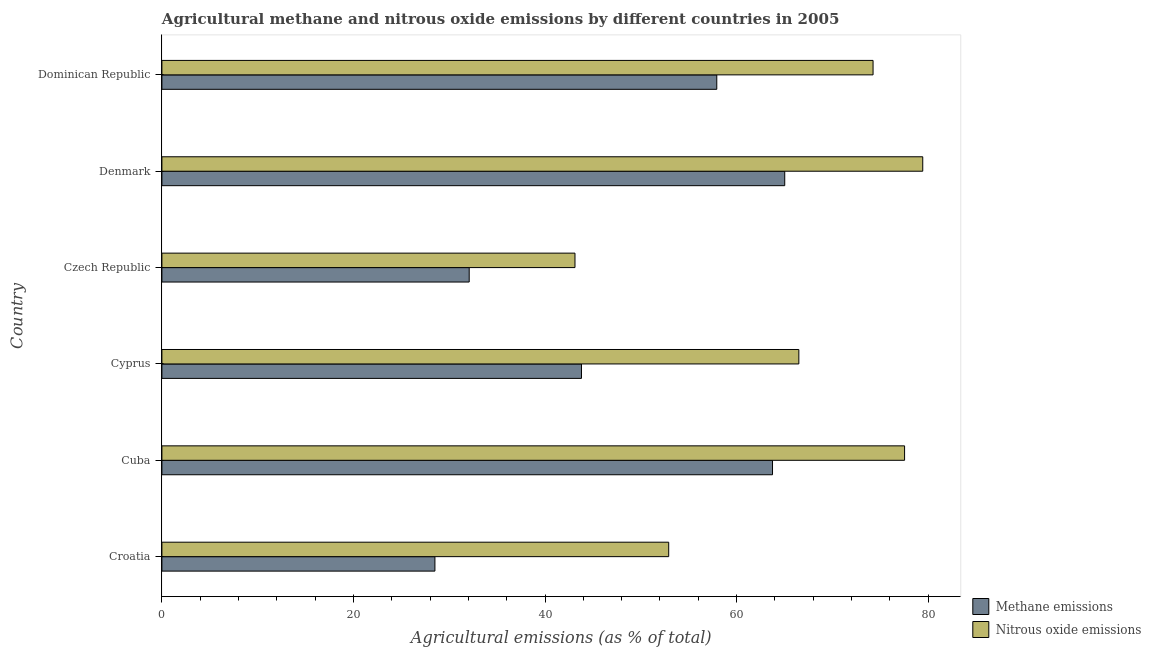How many different coloured bars are there?
Ensure brevity in your answer.  2. How many groups of bars are there?
Offer a terse response. 6. Are the number of bars per tick equal to the number of legend labels?
Offer a terse response. Yes. What is the label of the 2nd group of bars from the top?
Give a very brief answer. Denmark. In how many cases, is the number of bars for a given country not equal to the number of legend labels?
Offer a terse response. 0. What is the amount of methane emissions in Dominican Republic?
Offer a terse response. 57.94. Across all countries, what is the maximum amount of nitrous oxide emissions?
Your response must be concise. 79.44. Across all countries, what is the minimum amount of nitrous oxide emissions?
Your answer should be compact. 43.13. In which country was the amount of nitrous oxide emissions maximum?
Provide a short and direct response. Denmark. In which country was the amount of methane emissions minimum?
Provide a short and direct response. Croatia. What is the total amount of methane emissions in the graph?
Keep it short and to the point. 291.12. What is the difference between the amount of methane emissions in Croatia and that in Denmark?
Make the answer very short. -36.52. What is the difference between the amount of nitrous oxide emissions in Dominican Republic and the amount of methane emissions in Cuba?
Offer a very short reply. 10.5. What is the average amount of nitrous oxide emissions per country?
Your answer should be compact. 65.63. What is the difference between the amount of nitrous oxide emissions and amount of methane emissions in Dominican Republic?
Keep it short and to the point. 16.32. What is the ratio of the amount of methane emissions in Cuba to that in Denmark?
Your answer should be compact. 0.98. What is the difference between the highest and the second highest amount of methane emissions?
Your answer should be compact. 1.27. What is the difference between the highest and the lowest amount of nitrous oxide emissions?
Your answer should be very brief. 36.31. In how many countries, is the amount of nitrous oxide emissions greater than the average amount of nitrous oxide emissions taken over all countries?
Provide a short and direct response. 4. What does the 2nd bar from the top in Cyprus represents?
Keep it short and to the point. Methane emissions. What does the 1st bar from the bottom in Czech Republic represents?
Give a very brief answer. Methane emissions. How many bars are there?
Offer a terse response. 12. Are all the bars in the graph horizontal?
Keep it short and to the point. Yes. What is the difference between two consecutive major ticks on the X-axis?
Ensure brevity in your answer.  20. Are the values on the major ticks of X-axis written in scientific E-notation?
Offer a terse response. No. Does the graph contain any zero values?
Your answer should be very brief. No. Does the graph contain grids?
Keep it short and to the point. No. Where does the legend appear in the graph?
Ensure brevity in your answer.  Bottom right. How are the legend labels stacked?
Offer a very short reply. Vertical. What is the title of the graph?
Ensure brevity in your answer.  Agricultural methane and nitrous oxide emissions by different countries in 2005. What is the label or title of the X-axis?
Your answer should be very brief. Agricultural emissions (as % of total). What is the Agricultural emissions (as % of total) in Methane emissions in Croatia?
Give a very brief answer. 28.51. What is the Agricultural emissions (as % of total) of Nitrous oxide emissions in Croatia?
Provide a succinct answer. 52.91. What is the Agricultural emissions (as % of total) of Methane emissions in Cuba?
Make the answer very short. 63.76. What is the Agricultural emissions (as % of total) of Nitrous oxide emissions in Cuba?
Provide a succinct answer. 77.54. What is the Agricultural emissions (as % of total) of Methane emissions in Cyprus?
Your answer should be compact. 43.81. What is the Agricultural emissions (as % of total) of Nitrous oxide emissions in Cyprus?
Make the answer very short. 66.5. What is the Agricultural emissions (as % of total) in Methane emissions in Czech Republic?
Provide a short and direct response. 32.09. What is the Agricultural emissions (as % of total) of Nitrous oxide emissions in Czech Republic?
Your answer should be very brief. 43.13. What is the Agricultural emissions (as % of total) in Methane emissions in Denmark?
Offer a terse response. 65.03. What is the Agricultural emissions (as % of total) of Nitrous oxide emissions in Denmark?
Give a very brief answer. 79.44. What is the Agricultural emissions (as % of total) of Methane emissions in Dominican Republic?
Your response must be concise. 57.94. What is the Agricultural emissions (as % of total) of Nitrous oxide emissions in Dominican Republic?
Offer a terse response. 74.25. Across all countries, what is the maximum Agricultural emissions (as % of total) in Methane emissions?
Your answer should be compact. 65.03. Across all countries, what is the maximum Agricultural emissions (as % of total) of Nitrous oxide emissions?
Your answer should be very brief. 79.44. Across all countries, what is the minimum Agricultural emissions (as % of total) of Methane emissions?
Offer a very short reply. 28.51. Across all countries, what is the minimum Agricultural emissions (as % of total) in Nitrous oxide emissions?
Offer a terse response. 43.13. What is the total Agricultural emissions (as % of total) in Methane emissions in the graph?
Your answer should be compact. 291.12. What is the total Agricultural emissions (as % of total) of Nitrous oxide emissions in the graph?
Your answer should be very brief. 393.79. What is the difference between the Agricultural emissions (as % of total) in Methane emissions in Croatia and that in Cuba?
Your answer should be compact. -35.25. What is the difference between the Agricultural emissions (as % of total) in Nitrous oxide emissions in Croatia and that in Cuba?
Your answer should be compact. -24.63. What is the difference between the Agricultural emissions (as % of total) of Methane emissions in Croatia and that in Cyprus?
Keep it short and to the point. -15.3. What is the difference between the Agricultural emissions (as % of total) of Nitrous oxide emissions in Croatia and that in Cyprus?
Your answer should be compact. -13.59. What is the difference between the Agricultural emissions (as % of total) in Methane emissions in Croatia and that in Czech Republic?
Give a very brief answer. -3.58. What is the difference between the Agricultural emissions (as % of total) in Nitrous oxide emissions in Croatia and that in Czech Republic?
Offer a very short reply. 9.78. What is the difference between the Agricultural emissions (as % of total) of Methane emissions in Croatia and that in Denmark?
Keep it short and to the point. -36.52. What is the difference between the Agricultural emissions (as % of total) of Nitrous oxide emissions in Croatia and that in Denmark?
Give a very brief answer. -26.53. What is the difference between the Agricultural emissions (as % of total) of Methane emissions in Croatia and that in Dominican Republic?
Keep it short and to the point. -29.43. What is the difference between the Agricultural emissions (as % of total) of Nitrous oxide emissions in Croatia and that in Dominican Republic?
Give a very brief answer. -21.34. What is the difference between the Agricultural emissions (as % of total) in Methane emissions in Cuba and that in Cyprus?
Offer a terse response. 19.95. What is the difference between the Agricultural emissions (as % of total) in Nitrous oxide emissions in Cuba and that in Cyprus?
Keep it short and to the point. 11.04. What is the difference between the Agricultural emissions (as % of total) in Methane emissions in Cuba and that in Czech Republic?
Your response must be concise. 31.67. What is the difference between the Agricultural emissions (as % of total) in Nitrous oxide emissions in Cuba and that in Czech Republic?
Keep it short and to the point. 34.41. What is the difference between the Agricultural emissions (as % of total) in Methane emissions in Cuba and that in Denmark?
Offer a terse response. -1.28. What is the difference between the Agricultural emissions (as % of total) in Nitrous oxide emissions in Cuba and that in Denmark?
Your answer should be compact. -1.9. What is the difference between the Agricultural emissions (as % of total) in Methane emissions in Cuba and that in Dominican Republic?
Offer a terse response. 5.82. What is the difference between the Agricultural emissions (as % of total) of Nitrous oxide emissions in Cuba and that in Dominican Republic?
Keep it short and to the point. 3.29. What is the difference between the Agricultural emissions (as % of total) of Methane emissions in Cyprus and that in Czech Republic?
Your response must be concise. 11.72. What is the difference between the Agricultural emissions (as % of total) of Nitrous oxide emissions in Cyprus and that in Czech Republic?
Your answer should be compact. 23.37. What is the difference between the Agricultural emissions (as % of total) of Methane emissions in Cyprus and that in Denmark?
Offer a very short reply. -21.22. What is the difference between the Agricultural emissions (as % of total) in Nitrous oxide emissions in Cyprus and that in Denmark?
Offer a terse response. -12.94. What is the difference between the Agricultural emissions (as % of total) in Methane emissions in Cyprus and that in Dominican Republic?
Offer a very short reply. -14.13. What is the difference between the Agricultural emissions (as % of total) of Nitrous oxide emissions in Cyprus and that in Dominican Republic?
Your response must be concise. -7.75. What is the difference between the Agricultural emissions (as % of total) of Methane emissions in Czech Republic and that in Denmark?
Provide a short and direct response. -32.94. What is the difference between the Agricultural emissions (as % of total) in Nitrous oxide emissions in Czech Republic and that in Denmark?
Provide a short and direct response. -36.31. What is the difference between the Agricultural emissions (as % of total) of Methane emissions in Czech Republic and that in Dominican Republic?
Offer a terse response. -25.85. What is the difference between the Agricultural emissions (as % of total) of Nitrous oxide emissions in Czech Republic and that in Dominican Republic?
Provide a short and direct response. -31.12. What is the difference between the Agricultural emissions (as % of total) in Methane emissions in Denmark and that in Dominican Republic?
Offer a terse response. 7.1. What is the difference between the Agricultural emissions (as % of total) in Nitrous oxide emissions in Denmark and that in Dominican Republic?
Give a very brief answer. 5.19. What is the difference between the Agricultural emissions (as % of total) of Methane emissions in Croatia and the Agricultural emissions (as % of total) of Nitrous oxide emissions in Cuba?
Keep it short and to the point. -49.04. What is the difference between the Agricultural emissions (as % of total) in Methane emissions in Croatia and the Agricultural emissions (as % of total) in Nitrous oxide emissions in Cyprus?
Make the answer very short. -38. What is the difference between the Agricultural emissions (as % of total) in Methane emissions in Croatia and the Agricultural emissions (as % of total) in Nitrous oxide emissions in Czech Republic?
Provide a short and direct response. -14.62. What is the difference between the Agricultural emissions (as % of total) of Methane emissions in Croatia and the Agricultural emissions (as % of total) of Nitrous oxide emissions in Denmark?
Your response must be concise. -50.93. What is the difference between the Agricultural emissions (as % of total) in Methane emissions in Croatia and the Agricultural emissions (as % of total) in Nitrous oxide emissions in Dominican Republic?
Your answer should be compact. -45.75. What is the difference between the Agricultural emissions (as % of total) of Methane emissions in Cuba and the Agricultural emissions (as % of total) of Nitrous oxide emissions in Cyprus?
Keep it short and to the point. -2.75. What is the difference between the Agricultural emissions (as % of total) in Methane emissions in Cuba and the Agricultural emissions (as % of total) in Nitrous oxide emissions in Czech Republic?
Make the answer very short. 20.63. What is the difference between the Agricultural emissions (as % of total) in Methane emissions in Cuba and the Agricultural emissions (as % of total) in Nitrous oxide emissions in Denmark?
Provide a short and direct response. -15.69. What is the difference between the Agricultural emissions (as % of total) of Methane emissions in Cuba and the Agricultural emissions (as % of total) of Nitrous oxide emissions in Dominican Republic?
Your response must be concise. -10.5. What is the difference between the Agricultural emissions (as % of total) of Methane emissions in Cyprus and the Agricultural emissions (as % of total) of Nitrous oxide emissions in Czech Republic?
Your answer should be compact. 0.68. What is the difference between the Agricultural emissions (as % of total) of Methane emissions in Cyprus and the Agricultural emissions (as % of total) of Nitrous oxide emissions in Denmark?
Provide a succinct answer. -35.63. What is the difference between the Agricultural emissions (as % of total) in Methane emissions in Cyprus and the Agricultural emissions (as % of total) in Nitrous oxide emissions in Dominican Republic?
Make the answer very short. -30.45. What is the difference between the Agricultural emissions (as % of total) in Methane emissions in Czech Republic and the Agricultural emissions (as % of total) in Nitrous oxide emissions in Denmark?
Your response must be concise. -47.35. What is the difference between the Agricultural emissions (as % of total) of Methane emissions in Czech Republic and the Agricultural emissions (as % of total) of Nitrous oxide emissions in Dominican Republic?
Offer a very short reply. -42.17. What is the difference between the Agricultural emissions (as % of total) in Methane emissions in Denmark and the Agricultural emissions (as % of total) in Nitrous oxide emissions in Dominican Republic?
Offer a terse response. -9.22. What is the average Agricultural emissions (as % of total) in Methane emissions per country?
Offer a very short reply. 48.52. What is the average Agricultural emissions (as % of total) of Nitrous oxide emissions per country?
Provide a succinct answer. 65.63. What is the difference between the Agricultural emissions (as % of total) in Methane emissions and Agricultural emissions (as % of total) in Nitrous oxide emissions in Croatia?
Provide a short and direct response. -24.41. What is the difference between the Agricultural emissions (as % of total) of Methane emissions and Agricultural emissions (as % of total) of Nitrous oxide emissions in Cuba?
Make the answer very short. -13.79. What is the difference between the Agricultural emissions (as % of total) in Methane emissions and Agricultural emissions (as % of total) in Nitrous oxide emissions in Cyprus?
Ensure brevity in your answer.  -22.7. What is the difference between the Agricultural emissions (as % of total) in Methane emissions and Agricultural emissions (as % of total) in Nitrous oxide emissions in Czech Republic?
Give a very brief answer. -11.04. What is the difference between the Agricultural emissions (as % of total) of Methane emissions and Agricultural emissions (as % of total) of Nitrous oxide emissions in Denmark?
Your answer should be very brief. -14.41. What is the difference between the Agricultural emissions (as % of total) in Methane emissions and Agricultural emissions (as % of total) in Nitrous oxide emissions in Dominican Republic?
Provide a succinct answer. -16.32. What is the ratio of the Agricultural emissions (as % of total) in Methane emissions in Croatia to that in Cuba?
Offer a terse response. 0.45. What is the ratio of the Agricultural emissions (as % of total) of Nitrous oxide emissions in Croatia to that in Cuba?
Ensure brevity in your answer.  0.68. What is the ratio of the Agricultural emissions (as % of total) in Methane emissions in Croatia to that in Cyprus?
Your response must be concise. 0.65. What is the ratio of the Agricultural emissions (as % of total) of Nitrous oxide emissions in Croatia to that in Cyprus?
Provide a short and direct response. 0.8. What is the ratio of the Agricultural emissions (as % of total) of Methane emissions in Croatia to that in Czech Republic?
Your response must be concise. 0.89. What is the ratio of the Agricultural emissions (as % of total) in Nitrous oxide emissions in Croatia to that in Czech Republic?
Provide a succinct answer. 1.23. What is the ratio of the Agricultural emissions (as % of total) in Methane emissions in Croatia to that in Denmark?
Ensure brevity in your answer.  0.44. What is the ratio of the Agricultural emissions (as % of total) in Nitrous oxide emissions in Croatia to that in Denmark?
Give a very brief answer. 0.67. What is the ratio of the Agricultural emissions (as % of total) of Methane emissions in Croatia to that in Dominican Republic?
Keep it short and to the point. 0.49. What is the ratio of the Agricultural emissions (as % of total) in Nitrous oxide emissions in Croatia to that in Dominican Republic?
Ensure brevity in your answer.  0.71. What is the ratio of the Agricultural emissions (as % of total) of Methane emissions in Cuba to that in Cyprus?
Make the answer very short. 1.46. What is the ratio of the Agricultural emissions (as % of total) in Nitrous oxide emissions in Cuba to that in Cyprus?
Offer a very short reply. 1.17. What is the ratio of the Agricultural emissions (as % of total) in Methane emissions in Cuba to that in Czech Republic?
Your answer should be compact. 1.99. What is the ratio of the Agricultural emissions (as % of total) of Nitrous oxide emissions in Cuba to that in Czech Republic?
Keep it short and to the point. 1.8. What is the ratio of the Agricultural emissions (as % of total) of Methane emissions in Cuba to that in Denmark?
Offer a very short reply. 0.98. What is the ratio of the Agricultural emissions (as % of total) of Nitrous oxide emissions in Cuba to that in Denmark?
Your answer should be compact. 0.98. What is the ratio of the Agricultural emissions (as % of total) of Methane emissions in Cuba to that in Dominican Republic?
Provide a short and direct response. 1.1. What is the ratio of the Agricultural emissions (as % of total) of Nitrous oxide emissions in Cuba to that in Dominican Republic?
Offer a terse response. 1.04. What is the ratio of the Agricultural emissions (as % of total) of Methane emissions in Cyprus to that in Czech Republic?
Your answer should be very brief. 1.37. What is the ratio of the Agricultural emissions (as % of total) in Nitrous oxide emissions in Cyprus to that in Czech Republic?
Give a very brief answer. 1.54. What is the ratio of the Agricultural emissions (as % of total) of Methane emissions in Cyprus to that in Denmark?
Provide a short and direct response. 0.67. What is the ratio of the Agricultural emissions (as % of total) in Nitrous oxide emissions in Cyprus to that in Denmark?
Give a very brief answer. 0.84. What is the ratio of the Agricultural emissions (as % of total) in Methane emissions in Cyprus to that in Dominican Republic?
Ensure brevity in your answer.  0.76. What is the ratio of the Agricultural emissions (as % of total) in Nitrous oxide emissions in Cyprus to that in Dominican Republic?
Keep it short and to the point. 0.9. What is the ratio of the Agricultural emissions (as % of total) in Methane emissions in Czech Republic to that in Denmark?
Give a very brief answer. 0.49. What is the ratio of the Agricultural emissions (as % of total) of Nitrous oxide emissions in Czech Republic to that in Denmark?
Your answer should be compact. 0.54. What is the ratio of the Agricultural emissions (as % of total) of Methane emissions in Czech Republic to that in Dominican Republic?
Offer a very short reply. 0.55. What is the ratio of the Agricultural emissions (as % of total) of Nitrous oxide emissions in Czech Republic to that in Dominican Republic?
Give a very brief answer. 0.58. What is the ratio of the Agricultural emissions (as % of total) of Methane emissions in Denmark to that in Dominican Republic?
Keep it short and to the point. 1.12. What is the ratio of the Agricultural emissions (as % of total) of Nitrous oxide emissions in Denmark to that in Dominican Republic?
Offer a very short reply. 1.07. What is the difference between the highest and the second highest Agricultural emissions (as % of total) of Methane emissions?
Provide a succinct answer. 1.28. What is the difference between the highest and the second highest Agricultural emissions (as % of total) in Nitrous oxide emissions?
Provide a succinct answer. 1.9. What is the difference between the highest and the lowest Agricultural emissions (as % of total) of Methane emissions?
Your answer should be very brief. 36.52. What is the difference between the highest and the lowest Agricultural emissions (as % of total) of Nitrous oxide emissions?
Provide a short and direct response. 36.31. 